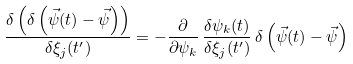Convert formula to latex. <formula><loc_0><loc_0><loc_500><loc_500>\frac { \delta \left ( \delta \left ( \vec { \psi } ( t ) - \vec { \psi } \right ) \right ) } { \delta \xi _ { j } ( t ^ { \prime } ) } = - \frac { \partial } { \partial \psi _ { k } } \, \frac { \delta \psi _ { k } ( t ) } { \delta \xi _ { j } ( t ^ { \prime } ) } \, \delta \left ( \vec { \psi } ( t ) - \vec { \psi } \right )</formula> 